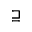Convert formula to latex. <formula><loc_0><loc_0><loc_500><loc_500>\sqsupseteq</formula> 